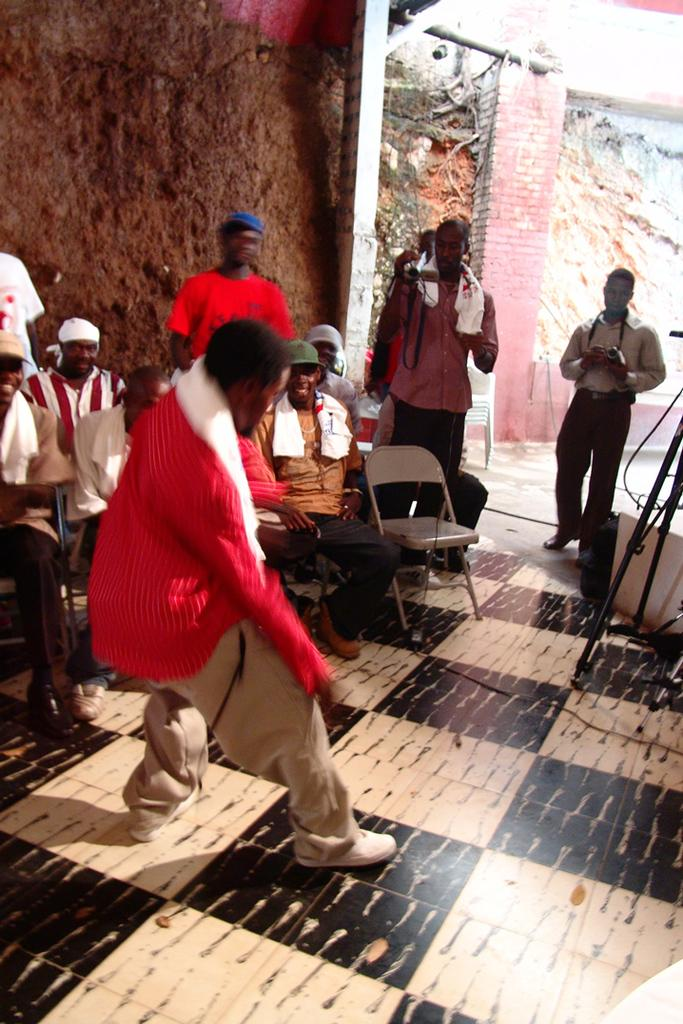What are the people in the image doing? There are people standing and sitting on chairs in the image. Can you describe the person holding an object in the image? A person is holding a camera in the image. What can be seen in the background of the image? There is a pillar visible in the background of the image. Where is the station located in the image? There is no station present in the image. What type of pickle is being used as a prop in the image? There is no pickle present in the image. 